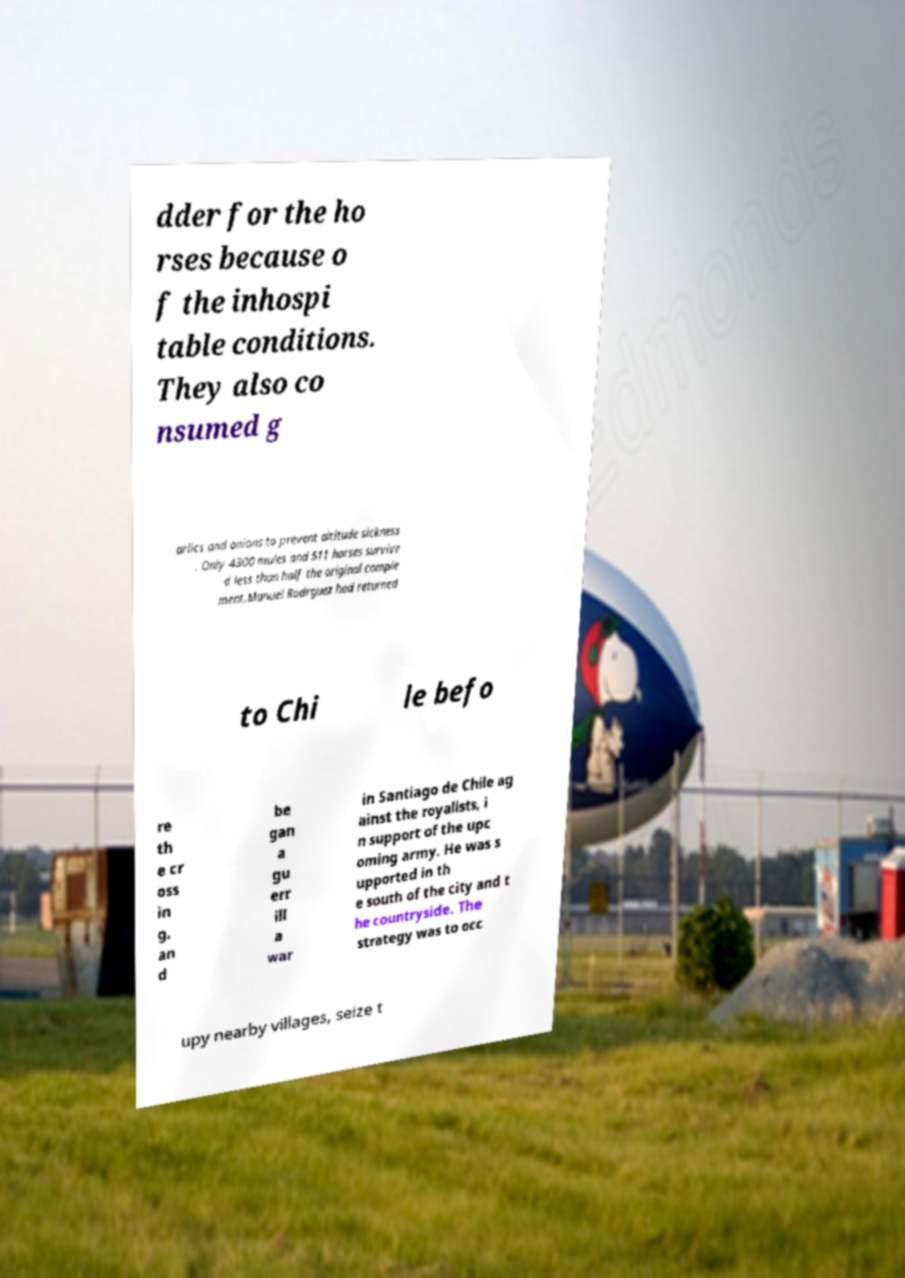I need the written content from this picture converted into text. Can you do that? dder for the ho rses because o f the inhospi table conditions. They also co nsumed g arlics and onions to prevent altitude sickness . Only 4300 mules and 511 horses survive d less than half the original comple ment.Manuel Rodrguez had returned to Chi le befo re th e cr oss in g, an d be gan a gu err ill a war in Santiago de Chile ag ainst the royalists, i n support of the upc oming army. He was s upported in th e south of the city and t he countryside. The strategy was to occ upy nearby villages, seize t 